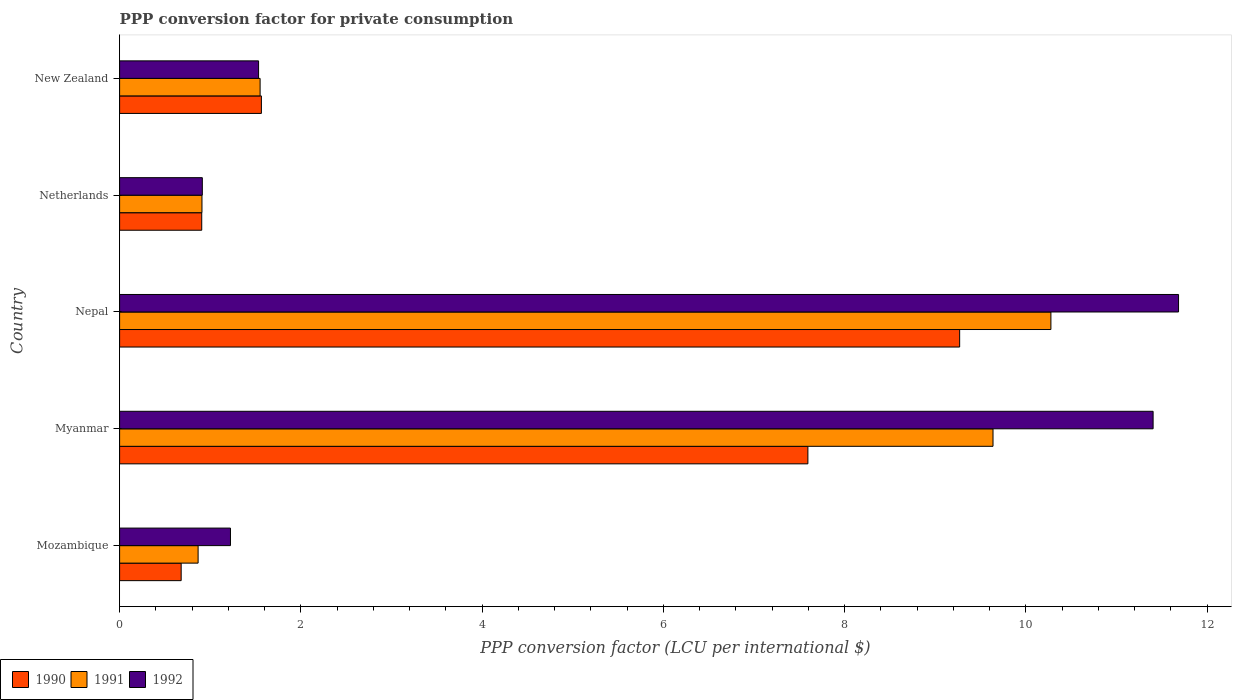Are the number of bars per tick equal to the number of legend labels?
Provide a short and direct response. Yes. How many bars are there on the 4th tick from the bottom?
Offer a very short reply. 3. What is the label of the 1st group of bars from the top?
Offer a terse response. New Zealand. In how many cases, is the number of bars for a given country not equal to the number of legend labels?
Provide a short and direct response. 0. What is the PPP conversion factor for private consumption in 1991 in Myanmar?
Give a very brief answer. 9.64. Across all countries, what is the maximum PPP conversion factor for private consumption in 1992?
Ensure brevity in your answer.  11.69. Across all countries, what is the minimum PPP conversion factor for private consumption in 1991?
Offer a terse response. 0.87. In which country was the PPP conversion factor for private consumption in 1990 maximum?
Offer a terse response. Nepal. In which country was the PPP conversion factor for private consumption in 1991 minimum?
Your answer should be compact. Mozambique. What is the total PPP conversion factor for private consumption in 1990 in the graph?
Your answer should be compact. 20.02. What is the difference between the PPP conversion factor for private consumption in 1991 in Mozambique and that in Nepal?
Your answer should be very brief. -9.41. What is the difference between the PPP conversion factor for private consumption in 1991 in New Zealand and the PPP conversion factor for private consumption in 1990 in Netherlands?
Provide a short and direct response. 0.64. What is the average PPP conversion factor for private consumption in 1990 per country?
Your response must be concise. 4. What is the difference between the PPP conversion factor for private consumption in 1992 and PPP conversion factor for private consumption in 1991 in Myanmar?
Your response must be concise. 1.77. What is the ratio of the PPP conversion factor for private consumption in 1992 in Myanmar to that in Nepal?
Your answer should be very brief. 0.98. Is the difference between the PPP conversion factor for private consumption in 1992 in Mozambique and Netherlands greater than the difference between the PPP conversion factor for private consumption in 1991 in Mozambique and Netherlands?
Offer a terse response. Yes. What is the difference between the highest and the second highest PPP conversion factor for private consumption in 1991?
Provide a succinct answer. 0.64. What is the difference between the highest and the lowest PPP conversion factor for private consumption in 1991?
Offer a very short reply. 9.41. Is the sum of the PPP conversion factor for private consumption in 1991 in Nepal and New Zealand greater than the maximum PPP conversion factor for private consumption in 1992 across all countries?
Keep it short and to the point. Yes. What does the 3rd bar from the top in Nepal represents?
Your answer should be compact. 1990. Is it the case that in every country, the sum of the PPP conversion factor for private consumption in 1991 and PPP conversion factor for private consumption in 1992 is greater than the PPP conversion factor for private consumption in 1990?
Ensure brevity in your answer.  Yes. Are all the bars in the graph horizontal?
Your answer should be compact. Yes. How many countries are there in the graph?
Offer a very short reply. 5. Does the graph contain any zero values?
Make the answer very short. No. How many legend labels are there?
Offer a very short reply. 3. What is the title of the graph?
Offer a very short reply. PPP conversion factor for private consumption. What is the label or title of the X-axis?
Provide a succinct answer. PPP conversion factor (LCU per international $). What is the PPP conversion factor (LCU per international $) of 1990 in Mozambique?
Offer a very short reply. 0.68. What is the PPP conversion factor (LCU per international $) in 1991 in Mozambique?
Ensure brevity in your answer.  0.87. What is the PPP conversion factor (LCU per international $) of 1992 in Mozambique?
Provide a succinct answer. 1.22. What is the PPP conversion factor (LCU per international $) in 1990 in Myanmar?
Provide a succinct answer. 7.6. What is the PPP conversion factor (LCU per international $) of 1991 in Myanmar?
Your answer should be very brief. 9.64. What is the PPP conversion factor (LCU per international $) in 1992 in Myanmar?
Your answer should be very brief. 11.41. What is the PPP conversion factor (LCU per international $) of 1990 in Nepal?
Offer a terse response. 9.27. What is the PPP conversion factor (LCU per international $) in 1991 in Nepal?
Your answer should be very brief. 10.28. What is the PPP conversion factor (LCU per international $) of 1992 in Nepal?
Give a very brief answer. 11.69. What is the PPP conversion factor (LCU per international $) of 1990 in Netherlands?
Your answer should be very brief. 0.91. What is the PPP conversion factor (LCU per international $) in 1991 in Netherlands?
Your answer should be very brief. 0.91. What is the PPP conversion factor (LCU per international $) of 1992 in Netherlands?
Your answer should be very brief. 0.91. What is the PPP conversion factor (LCU per international $) of 1990 in New Zealand?
Keep it short and to the point. 1.56. What is the PPP conversion factor (LCU per international $) of 1991 in New Zealand?
Provide a succinct answer. 1.55. What is the PPP conversion factor (LCU per international $) in 1992 in New Zealand?
Provide a short and direct response. 1.53. Across all countries, what is the maximum PPP conversion factor (LCU per international $) in 1990?
Your answer should be very brief. 9.27. Across all countries, what is the maximum PPP conversion factor (LCU per international $) in 1991?
Offer a very short reply. 10.28. Across all countries, what is the maximum PPP conversion factor (LCU per international $) of 1992?
Offer a terse response. 11.69. Across all countries, what is the minimum PPP conversion factor (LCU per international $) of 1990?
Ensure brevity in your answer.  0.68. Across all countries, what is the minimum PPP conversion factor (LCU per international $) in 1991?
Your answer should be very brief. 0.87. Across all countries, what is the minimum PPP conversion factor (LCU per international $) in 1992?
Offer a terse response. 0.91. What is the total PPP conversion factor (LCU per international $) of 1990 in the graph?
Offer a terse response. 20.02. What is the total PPP conversion factor (LCU per international $) in 1991 in the graph?
Provide a short and direct response. 23.24. What is the total PPP conversion factor (LCU per international $) of 1992 in the graph?
Give a very brief answer. 26.76. What is the difference between the PPP conversion factor (LCU per international $) in 1990 in Mozambique and that in Myanmar?
Offer a terse response. -6.92. What is the difference between the PPP conversion factor (LCU per international $) of 1991 in Mozambique and that in Myanmar?
Provide a short and direct response. -8.77. What is the difference between the PPP conversion factor (LCU per international $) in 1992 in Mozambique and that in Myanmar?
Your answer should be very brief. -10.18. What is the difference between the PPP conversion factor (LCU per international $) in 1990 in Mozambique and that in Nepal?
Give a very brief answer. -8.59. What is the difference between the PPP conversion factor (LCU per international $) in 1991 in Mozambique and that in Nepal?
Your answer should be compact. -9.41. What is the difference between the PPP conversion factor (LCU per international $) of 1992 in Mozambique and that in Nepal?
Offer a very short reply. -10.46. What is the difference between the PPP conversion factor (LCU per international $) in 1990 in Mozambique and that in Netherlands?
Your answer should be very brief. -0.23. What is the difference between the PPP conversion factor (LCU per international $) of 1991 in Mozambique and that in Netherlands?
Keep it short and to the point. -0.04. What is the difference between the PPP conversion factor (LCU per international $) in 1992 in Mozambique and that in Netherlands?
Your answer should be very brief. 0.31. What is the difference between the PPP conversion factor (LCU per international $) in 1990 in Mozambique and that in New Zealand?
Your answer should be very brief. -0.89. What is the difference between the PPP conversion factor (LCU per international $) in 1991 in Mozambique and that in New Zealand?
Keep it short and to the point. -0.68. What is the difference between the PPP conversion factor (LCU per international $) of 1992 in Mozambique and that in New Zealand?
Your answer should be compact. -0.31. What is the difference between the PPP conversion factor (LCU per international $) of 1990 in Myanmar and that in Nepal?
Your answer should be very brief. -1.67. What is the difference between the PPP conversion factor (LCU per international $) in 1991 in Myanmar and that in Nepal?
Provide a succinct answer. -0.64. What is the difference between the PPP conversion factor (LCU per international $) in 1992 in Myanmar and that in Nepal?
Your answer should be compact. -0.28. What is the difference between the PPP conversion factor (LCU per international $) in 1990 in Myanmar and that in Netherlands?
Make the answer very short. 6.69. What is the difference between the PPP conversion factor (LCU per international $) of 1991 in Myanmar and that in Netherlands?
Keep it short and to the point. 8.73. What is the difference between the PPP conversion factor (LCU per international $) of 1992 in Myanmar and that in Netherlands?
Give a very brief answer. 10.49. What is the difference between the PPP conversion factor (LCU per international $) of 1990 in Myanmar and that in New Zealand?
Make the answer very short. 6.03. What is the difference between the PPP conversion factor (LCU per international $) in 1991 in Myanmar and that in New Zealand?
Ensure brevity in your answer.  8.09. What is the difference between the PPP conversion factor (LCU per international $) in 1992 in Myanmar and that in New Zealand?
Ensure brevity in your answer.  9.87. What is the difference between the PPP conversion factor (LCU per international $) in 1990 in Nepal and that in Netherlands?
Ensure brevity in your answer.  8.36. What is the difference between the PPP conversion factor (LCU per international $) in 1991 in Nepal and that in Netherlands?
Give a very brief answer. 9.37. What is the difference between the PPP conversion factor (LCU per international $) of 1992 in Nepal and that in Netherlands?
Make the answer very short. 10.77. What is the difference between the PPP conversion factor (LCU per international $) in 1990 in Nepal and that in New Zealand?
Make the answer very short. 7.71. What is the difference between the PPP conversion factor (LCU per international $) in 1991 in Nepal and that in New Zealand?
Your response must be concise. 8.73. What is the difference between the PPP conversion factor (LCU per international $) of 1992 in Nepal and that in New Zealand?
Your answer should be compact. 10.15. What is the difference between the PPP conversion factor (LCU per international $) of 1990 in Netherlands and that in New Zealand?
Ensure brevity in your answer.  -0.66. What is the difference between the PPP conversion factor (LCU per international $) of 1991 in Netherlands and that in New Zealand?
Ensure brevity in your answer.  -0.64. What is the difference between the PPP conversion factor (LCU per international $) in 1992 in Netherlands and that in New Zealand?
Make the answer very short. -0.62. What is the difference between the PPP conversion factor (LCU per international $) in 1990 in Mozambique and the PPP conversion factor (LCU per international $) in 1991 in Myanmar?
Your response must be concise. -8.96. What is the difference between the PPP conversion factor (LCU per international $) in 1990 in Mozambique and the PPP conversion factor (LCU per international $) in 1992 in Myanmar?
Your response must be concise. -10.73. What is the difference between the PPP conversion factor (LCU per international $) in 1991 in Mozambique and the PPP conversion factor (LCU per international $) in 1992 in Myanmar?
Your answer should be very brief. -10.54. What is the difference between the PPP conversion factor (LCU per international $) of 1990 in Mozambique and the PPP conversion factor (LCU per international $) of 1991 in Nepal?
Your answer should be compact. -9.6. What is the difference between the PPP conversion factor (LCU per international $) in 1990 in Mozambique and the PPP conversion factor (LCU per international $) in 1992 in Nepal?
Offer a very short reply. -11.01. What is the difference between the PPP conversion factor (LCU per international $) in 1991 in Mozambique and the PPP conversion factor (LCU per international $) in 1992 in Nepal?
Provide a succinct answer. -10.82. What is the difference between the PPP conversion factor (LCU per international $) in 1990 in Mozambique and the PPP conversion factor (LCU per international $) in 1991 in Netherlands?
Your answer should be compact. -0.23. What is the difference between the PPP conversion factor (LCU per international $) of 1990 in Mozambique and the PPP conversion factor (LCU per international $) of 1992 in Netherlands?
Your response must be concise. -0.23. What is the difference between the PPP conversion factor (LCU per international $) of 1991 in Mozambique and the PPP conversion factor (LCU per international $) of 1992 in Netherlands?
Provide a short and direct response. -0.05. What is the difference between the PPP conversion factor (LCU per international $) in 1990 in Mozambique and the PPP conversion factor (LCU per international $) in 1991 in New Zealand?
Your response must be concise. -0.87. What is the difference between the PPP conversion factor (LCU per international $) in 1990 in Mozambique and the PPP conversion factor (LCU per international $) in 1992 in New Zealand?
Ensure brevity in your answer.  -0.85. What is the difference between the PPP conversion factor (LCU per international $) of 1991 in Mozambique and the PPP conversion factor (LCU per international $) of 1992 in New Zealand?
Your answer should be compact. -0.67. What is the difference between the PPP conversion factor (LCU per international $) of 1990 in Myanmar and the PPP conversion factor (LCU per international $) of 1991 in Nepal?
Make the answer very short. -2.68. What is the difference between the PPP conversion factor (LCU per international $) in 1990 in Myanmar and the PPP conversion factor (LCU per international $) in 1992 in Nepal?
Your response must be concise. -4.09. What is the difference between the PPP conversion factor (LCU per international $) of 1991 in Myanmar and the PPP conversion factor (LCU per international $) of 1992 in Nepal?
Keep it short and to the point. -2.05. What is the difference between the PPP conversion factor (LCU per international $) in 1990 in Myanmar and the PPP conversion factor (LCU per international $) in 1991 in Netherlands?
Make the answer very short. 6.69. What is the difference between the PPP conversion factor (LCU per international $) in 1990 in Myanmar and the PPP conversion factor (LCU per international $) in 1992 in Netherlands?
Offer a very short reply. 6.68. What is the difference between the PPP conversion factor (LCU per international $) in 1991 in Myanmar and the PPP conversion factor (LCU per international $) in 1992 in Netherlands?
Offer a very short reply. 8.73. What is the difference between the PPP conversion factor (LCU per international $) of 1990 in Myanmar and the PPP conversion factor (LCU per international $) of 1991 in New Zealand?
Your response must be concise. 6.05. What is the difference between the PPP conversion factor (LCU per international $) of 1990 in Myanmar and the PPP conversion factor (LCU per international $) of 1992 in New Zealand?
Ensure brevity in your answer.  6.06. What is the difference between the PPP conversion factor (LCU per international $) of 1991 in Myanmar and the PPP conversion factor (LCU per international $) of 1992 in New Zealand?
Your response must be concise. 8.1. What is the difference between the PPP conversion factor (LCU per international $) in 1990 in Nepal and the PPP conversion factor (LCU per international $) in 1991 in Netherlands?
Your answer should be very brief. 8.36. What is the difference between the PPP conversion factor (LCU per international $) of 1990 in Nepal and the PPP conversion factor (LCU per international $) of 1992 in Netherlands?
Your answer should be very brief. 8.36. What is the difference between the PPP conversion factor (LCU per international $) of 1991 in Nepal and the PPP conversion factor (LCU per international $) of 1992 in Netherlands?
Provide a short and direct response. 9.36. What is the difference between the PPP conversion factor (LCU per international $) of 1990 in Nepal and the PPP conversion factor (LCU per international $) of 1991 in New Zealand?
Your answer should be very brief. 7.72. What is the difference between the PPP conversion factor (LCU per international $) in 1990 in Nepal and the PPP conversion factor (LCU per international $) in 1992 in New Zealand?
Offer a very short reply. 7.74. What is the difference between the PPP conversion factor (LCU per international $) of 1991 in Nepal and the PPP conversion factor (LCU per international $) of 1992 in New Zealand?
Offer a terse response. 8.74. What is the difference between the PPP conversion factor (LCU per international $) in 1990 in Netherlands and the PPP conversion factor (LCU per international $) in 1991 in New Zealand?
Provide a short and direct response. -0.64. What is the difference between the PPP conversion factor (LCU per international $) in 1990 in Netherlands and the PPP conversion factor (LCU per international $) in 1992 in New Zealand?
Provide a short and direct response. -0.63. What is the difference between the PPP conversion factor (LCU per international $) of 1991 in Netherlands and the PPP conversion factor (LCU per international $) of 1992 in New Zealand?
Offer a very short reply. -0.62. What is the average PPP conversion factor (LCU per international $) in 1990 per country?
Your answer should be compact. 4. What is the average PPP conversion factor (LCU per international $) of 1991 per country?
Offer a terse response. 4.65. What is the average PPP conversion factor (LCU per international $) of 1992 per country?
Provide a succinct answer. 5.35. What is the difference between the PPP conversion factor (LCU per international $) in 1990 and PPP conversion factor (LCU per international $) in 1991 in Mozambique?
Your answer should be compact. -0.19. What is the difference between the PPP conversion factor (LCU per international $) in 1990 and PPP conversion factor (LCU per international $) in 1992 in Mozambique?
Offer a very short reply. -0.54. What is the difference between the PPP conversion factor (LCU per international $) of 1991 and PPP conversion factor (LCU per international $) of 1992 in Mozambique?
Offer a very short reply. -0.36. What is the difference between the PPP conversion factor (LCU per international $) of 1990 and PPP conversion factor (LCU per international $) of 1991 in Myanmar?
Offer a terse response. -2.04. What is the difference between the PPP conversion factor (LCU per international $) of 1990 and PPP conversion factor (LCU per international $) of 1992 in Myanmar?
Give a very brief answer. -3.81. What is the difference between the PPP conversion factor (LCU per international $) in 1991 and PPP conversion factor (LCU per international $) in 1992 in Myanmar?
Ensure brevity in your answer.  -1.77. What is the difference between the PPP conversion factor (LCU per international $) of 1990 and PPP conversion factor (LCU per international $) of 1991 in Nepal?
Provide a short and direct response. -1.01. What is the difference between the PPP conversion factor (LCU per international $) in 1990 and PPP conversion factor (LCU per international $) in 1992 in Nepal?
Your answer should be very brief. -2.42. What is the difference between the PPP conversion factor (LCU per international $) of 1991 and PPP conversion factor (LCU per international $) of 1992 in Nepal?
Provide a short and direct response. -1.41. What is the difference between the PPP conversion factor (LCU per international $) of 1990 and PPP conversion factor (LCU per international $) of 1991 in Netherlands?
Provide a short and direct response. -0. What is the difference between the PPP conversion factor (LCU per international $) of 1990 and PPP conversion factor (LCU per international $) of 1992 in Netherlands?
Offer a terse response. -0.01. What is the difference between the PPP conversion factor (LCU per international $) in 1991 and PPP conversion factor (LCU per international $) in 1992 in Netherlands?
Give a very brief answer. -0. What is the difference between the PPP conversion factor (LCU per international $) of 1990 and PPP conversion factor (LCU per international $) of 1991 in New Zealand?
Your response must be concise. 0.01. What is the difference between the PPP conversion factor (LCU per international $) of 1990 and PPP conversion factor (LCU per international $) of 1992 in New Zealand?
Your response must be concise. 0.03. What is the difference between the PPP conversion factor (LCU per international $) in 1991 and PPP conversion factor (LCU per international $) in 1992 in New Zealand?
Your answer should be very brief. 0.02. What is the ratio of the PPP conversion factor (LCU per international $) in 1990 in Mozambique to that in Myanmar?
Offer a very short reply. 0.09. What is the ratio of the PPP conversion factor (LCU per international $) in 1991 in Mozambique to that in Myanmar?
Provide a short and direct response. 0.09. What is the ratio of the PPP conversion factor (LCU per international $) in 1992 in Mozambique to that in Myanmar?
Offer a terse response. 0.11. What is the ratio of the PPP conversion factor (LCU per international $) in 1990 in Mozambique to that in Nepal?
Offer a very short reply. 0.07. What is the ratio of the PPP conversion factor (LCU per international $) of 1991 in Mozambique to that in Nepal?
Offer a very short reply. 0.08. What is the ratio of the PPP conversion factor (LCU per international $) of 1992 in Mozambique to that in Nepal?
Your answer should be compact. 0.1. What is the ratio of the PPP conversion factor (LCU per international $) in 1990 in Mozambique to that in Netherlands?
Provide a short and direct response. 0.75. What is the ratio of the PPP conversion factor (LCU per international $) in 1991 in Mozambique to that in Netherlands?
Your answer should be very brief. 0.95. What is the ratio of the PPP conversion factor (LCU per international $) in 1992 in Mozambique to that in Netherlands?
Your answer should be compact. 1.34. What is the ratio of the PPP conversion factor (LCU per international $) of 1990 in Mozambique to that in New Zealand?
Provide a short and direct response. 0.43. What is the ratio of the PPP conversion factor (LCU per international $) in 1991 in Mozambique to that in New Zealand?
Make the answer very short. 0.56. What is the ratio of the PPP conversion factor (LCU per international $) of 1992 in Mozambique to that in New Zealand?
Make the answer very short. 0.8. What is the ratio of the PPP conversion factor (LCU per international $) in 1990 in Myanmar to that in Nepal?
Ensure brevity in your answer.  0.82. What is the ratio of the PPP conversion factor (LCU per international $) in 1991 in Myanmar to that in Nepal?
Provide a short and direct response. 0.94. What is the ratio of the PPP conversion factor (LCU per international $) of 1990 in Myanmar to that in Netherlands?
Offer a terse response. 8.38. What is the ratio of the PPP conversion factor (LCU per international $) in 1991 in Myanmar to that in Netherlands?
Offer a terse response. 10.6. What is the ratio of the PPP conversion factor (LCU per international $) in 1992 in Myanmar to that in Netherlands?
Ensure brevity in your answer.  12.49. What is the ratio of the PPP conversion factor (LCU per international $) in 1990 in Myanmar to that in New Zealand?
Offer a terse response. 4.85. What is the ratio of the PPP conversion factor (LCU per international $) in 1991 in Myanmar to that in New Zealand?
Provide a succinct answer. 6.22. What is the ratio of the PPP conversion factor (LCU per international $) of 1992 in Myanmar to that in New Zealand?
Give a very brief answer. 7.44. What is the ratio of the PPP conversion factor (LCU per international $) in 1990 in Nepal to that in Netherlands?
Make the answer very short. 10.23. What is the ratio of the PPP conversion factor (LCU per international $) of 1991 in Nepal to that in Netherlands?
Your answer should be very brief. 11.31. What is the ratio of the PPP conversion factor (LCU per international $) of 1992 in Nepal to that in Netherlands?
Keep it short and to the point. 12.8. What is the ratio of the PPP conversion factor (LCU per international $) in 1990 in Nepal to that in New Zealand?
Your answer should be very brief. 5.92. What is the ratio of the PPP conversion factor (LCU per international $) in 1991 in Nepal to that in New Zealand?
Your response must be concise. 6.63. What is the ratio of the PPP conversion factor (LCU per international $) of 1992 in Nepal to that in New Zealand?
Ensure brevity in your answer.  7.62. What is the ratio of the PPP conversion factor (LCU per international $) in 1990 in Netherlands to that in New Zealand?
Offer a terse response. 0.58. What is the ratio of the PPP conversion factor (LCU per international $) of 1991 in Netherlands to that in New Zealand?
Your answer should be very brief. 0.59. What is the ratio of the PPP conversion factor (LCU per international $) of 1992 in Netherlands to that in New Zealand?
Offer a very short reply. 0.6. What is the difference between the highest and the second highest PPP conversion factor (LCU per international $) in 1990?
Ensure brevity in your answer.  1.67. What is the difference between the highest and the second highest PPP conversion factor (LCU per international $) of 1991?
Offer a terse response. 0.64. What is the difference between the highest and the second highest PPP conversion factor (LCU per international $) of 1992?
Provide a succinct answer. 0.28. What is the difference between the highest and the lowest PPP conversion factor (LCU per international $) of 1990?
Your answer should be very brief. 8.59. What is the difference between the highest and the lowest PPP conversion factor (LCU per international $) in 1991?
Keep it short and to the point. 9.41. What is the difference between the highest and the lowest PPP conversion factor (LCU per international $) in 1992?
Ensure brevity in your answer.  10.77. 